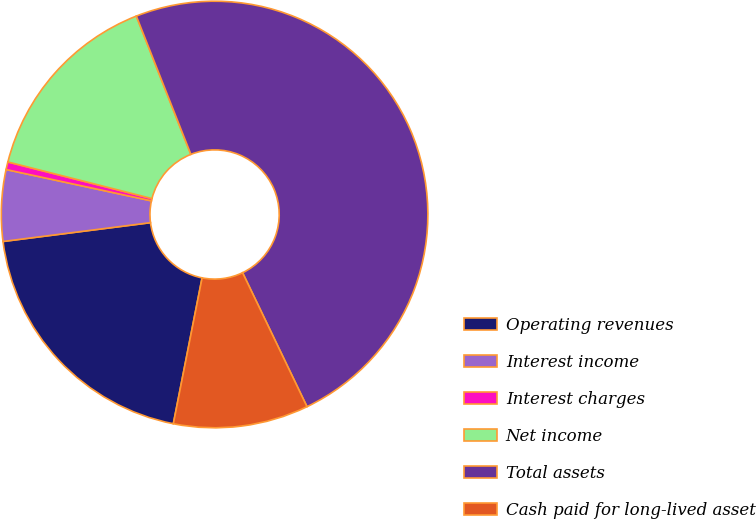Convert chart. <chart><loc_0><loc_0><loc_500><loc_500><pie_chart><fcel>Operating revenues<fcel>Interest income<fcel>Interest charges<fcel>Net income<fcel>Total assets<fcel>Cash paid for long-lived asset<nl><fcel>19.88%<fcel>5.4%<fcel>0.58%<fcel>15.06%<fcel>48.84%<fcel>10.23%<nl></chart> 